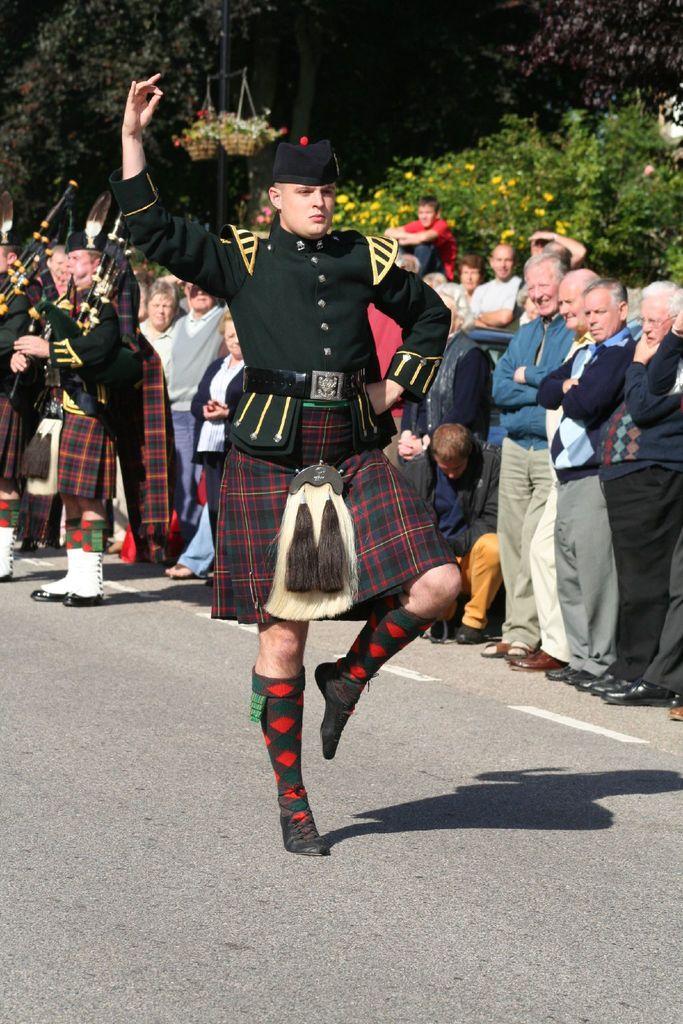How would you summarize this image in a sentence or two? In this image we can see a group of people standing on the ground. One person is wearing uniform and a cap. Two persons are holding bagpipes in their hands. In the background, we can see plants in two baskets, flowers on the trees and a group of trees. 